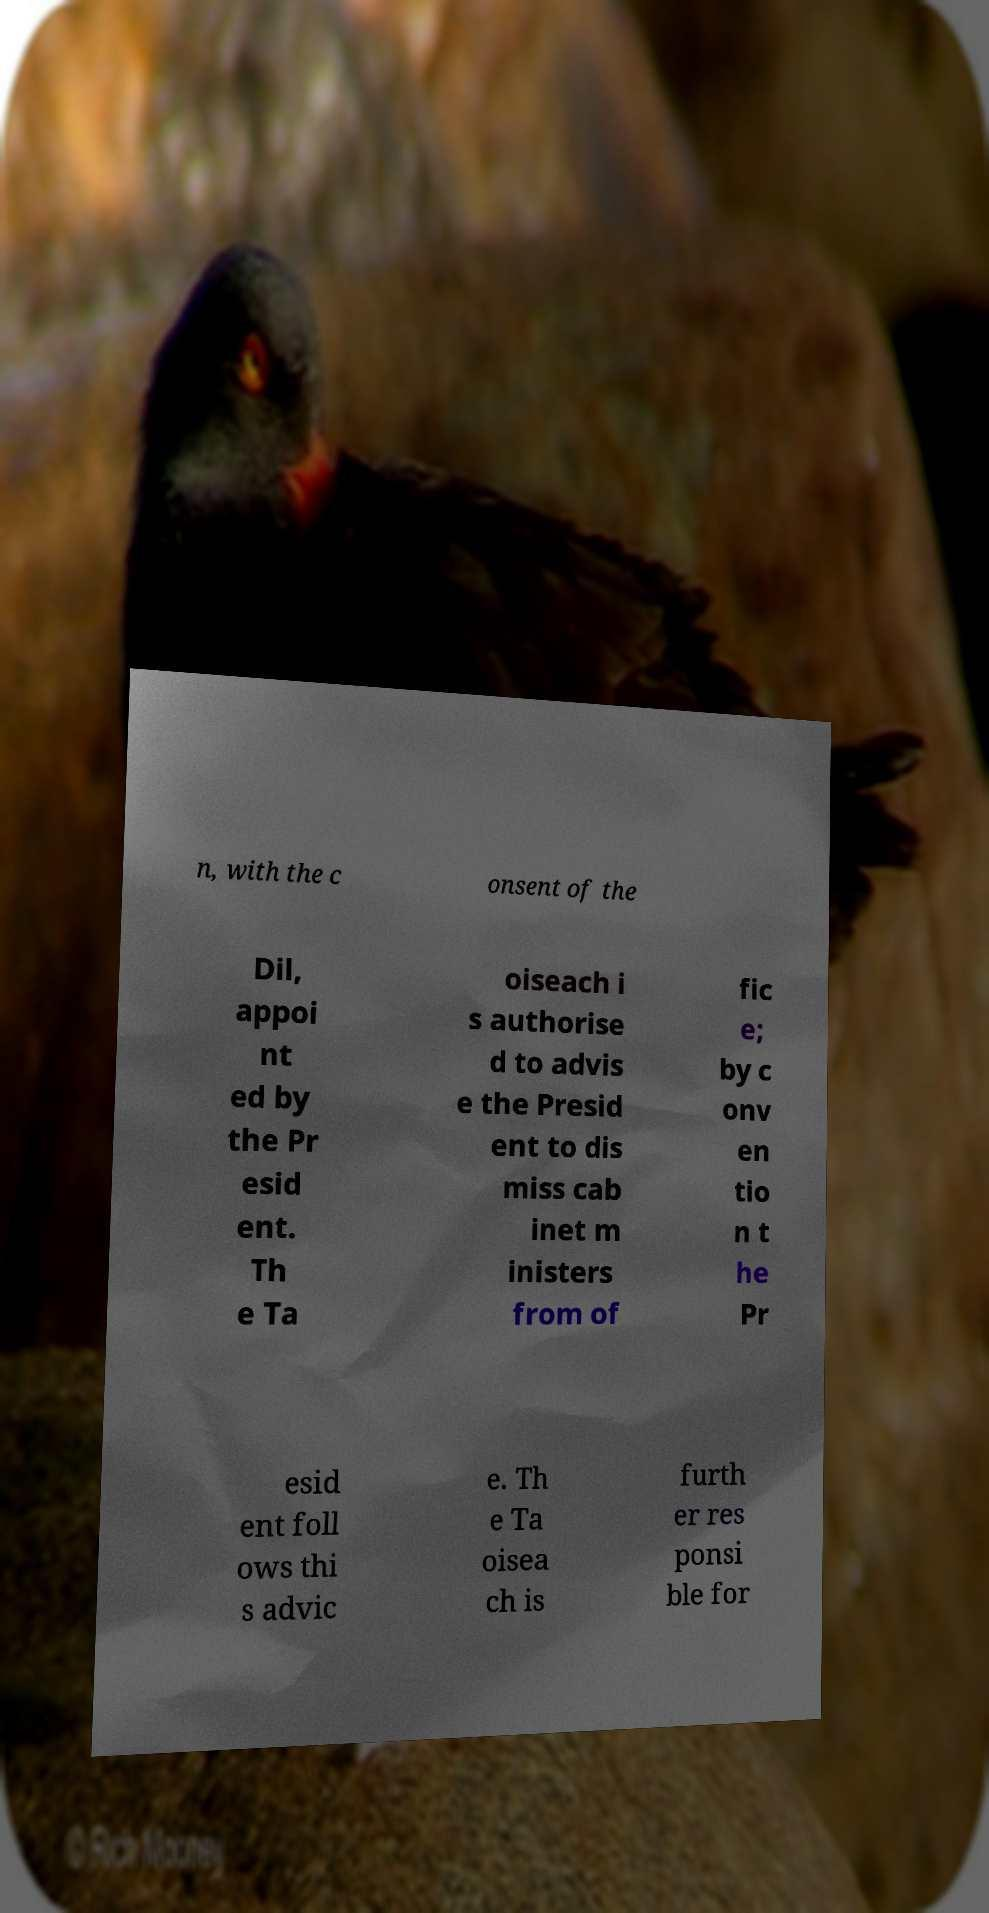Can you read and provide the text displayed in the image?This photo seems to have some interesting text. Can you extract and type it out for me? n, with the c onsent of the Dil, appoi nt ed by the Pr esid ent. Th e Ta oiseach i s authorise d to advis e the Presid ent to dis miss cab inet m inisters from of fic e; by c onv en tio n t he Pr esid ent foll ows thi s advic e. Th e Ta oisea ch is furth er res ponsi ble for 